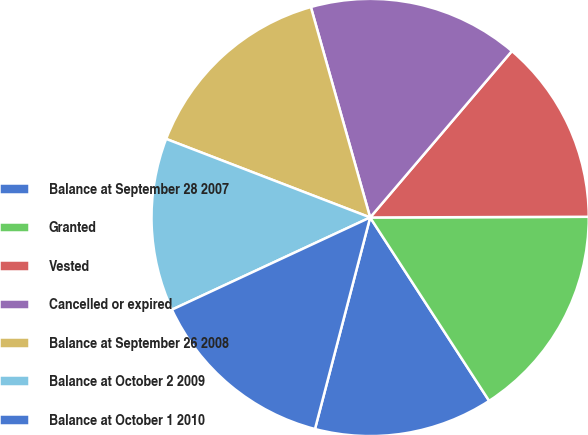Convert chart. <chart><loc_0><loc_0><loc_500><loc_500><pie_chart><fcel>Balance at September 28 2007<fcel>Granted<fcel>Vested<fcel>Cancelled or expired<fcel>Balance at September 26 2008<fcel>Balance at October 2 2009<fcel>Balance at October 1 2010<nl><fcel>13.22%<fcel>15.89%<fcel>13.72%<fcel>15.6%<fcel>14.78%<fcel>12.78%<fcel>14.01%<nl></chart> 